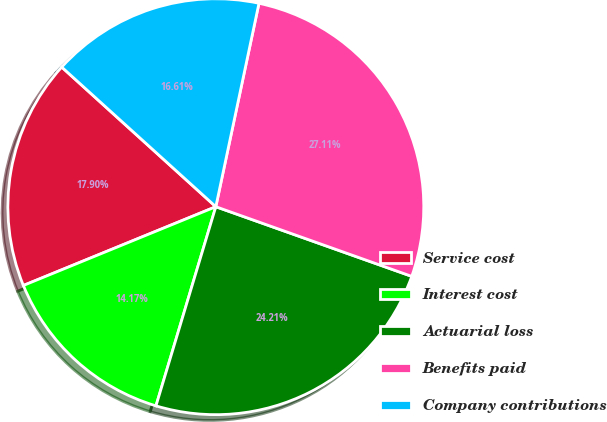Convert chart. <chart><loc_0><loc_0><loc_500><loc_500><pie_chart><fcel>Service cost<fcel>Interest cost<fcel>Actuarial loss<fcel>Benefits paid<fcel>Company contributions<nl><fcel>17.9%<fcel>14.17%<fcel>24.21%<fcel>27.11%<fcel>16.61%<nl></chart> 